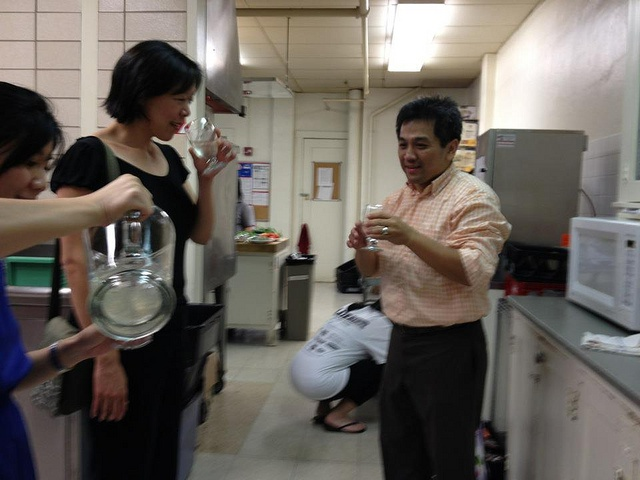Describe the objects in this image and their specific colors. I can see people in darkgray, black, gray, and maroon tones, people in darkgray, black, maroon, gray, and brown tones, people in darkgray, black, maroon, and gray tones, people in darkgray, black, and gray tones, and microwave in darkgray and gray tones in this image. 